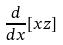Convert formula to latex. <formula><loc_0><loc_0><loc_500><loc_500>\frac { d } { d x } [ x z ]</formula> 